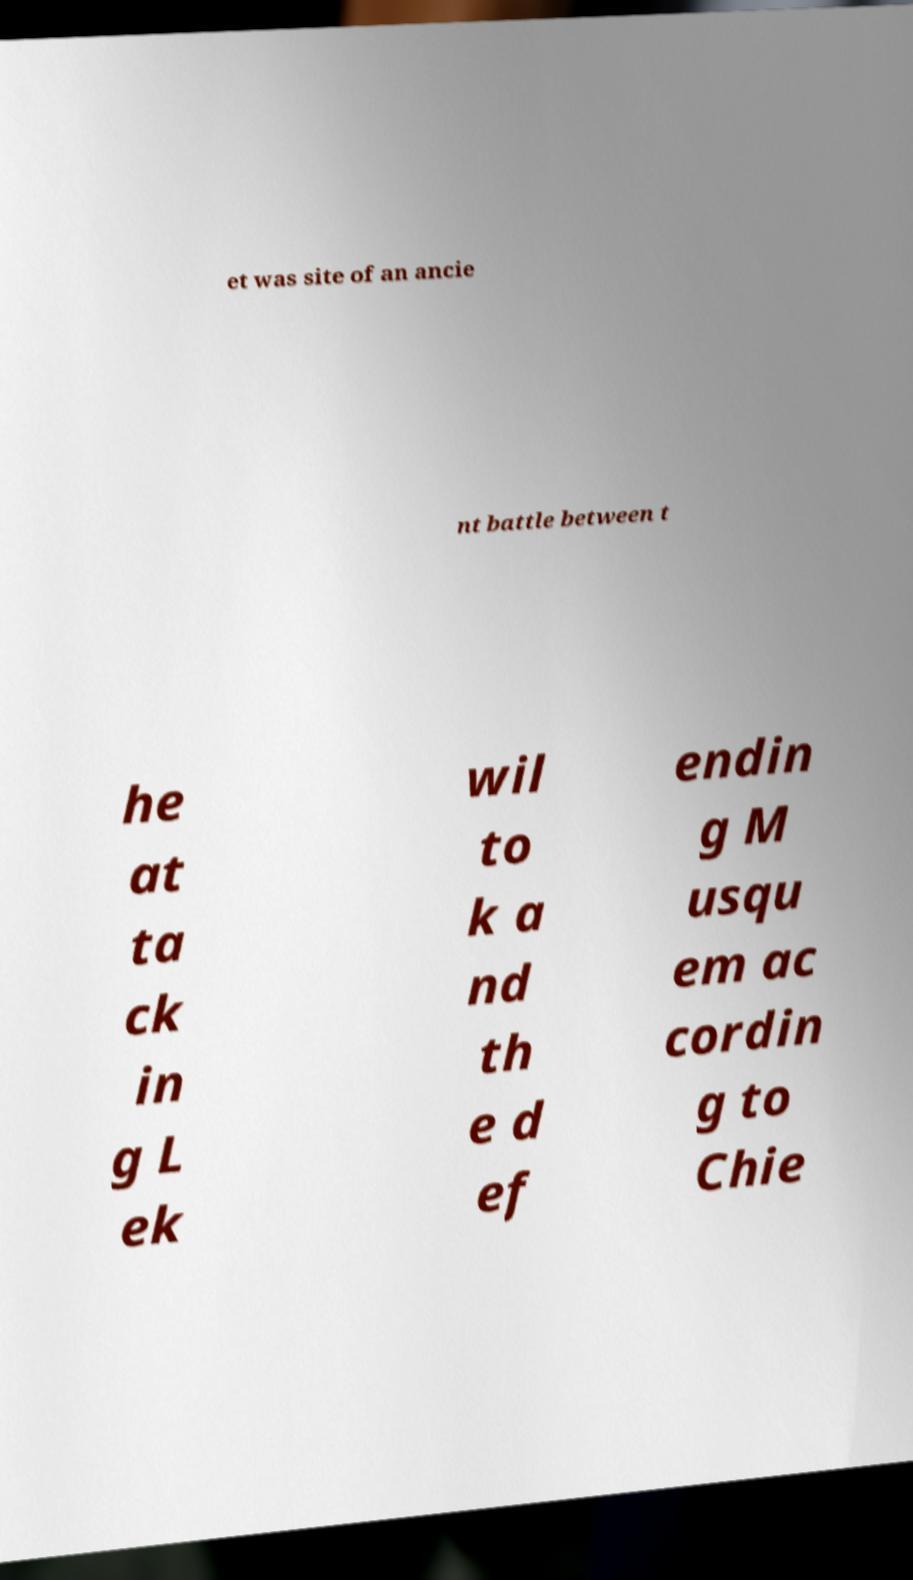There's text embedded in this image that I need extracted. Can you transcribe it verbatim? et was site of an ancie nt battle between t he at ta ck in g L ek wil to k a nd th e d ef endin g M usqu em ac cordin g to Chie 